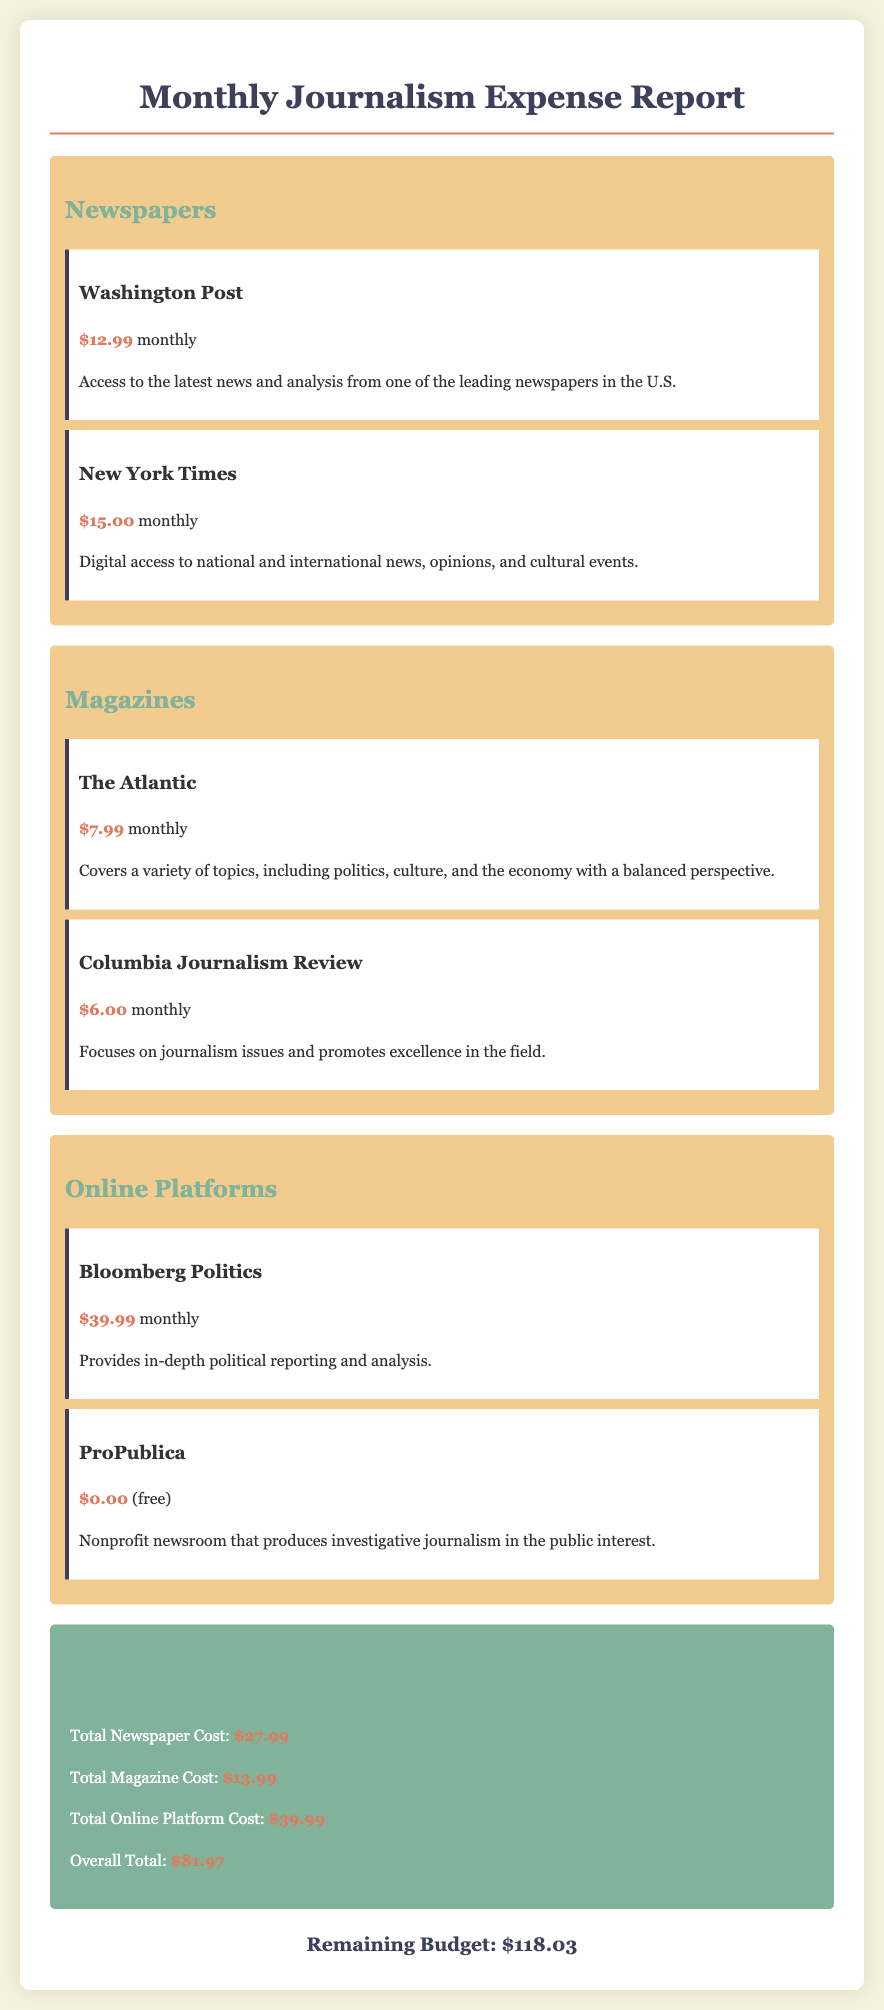What is the total cost for newspapers? The total cost for newspapers is calculated by adding the individual costs of the Washington Post and the New York Times, which are $12.99 and $15.00, respectively.
Answer: $27.99 How much does a subscription to The Atlantic cost? The cost of a subscription to The Atlantic is listed directly under its description.
Answer: $7.99 What is the overall total monthly expense? The overall total monthly expense is clearly stated in the summary section of the document.
Answer: $81.97 How many magazines are listed in the report? The number of magazines is determined by counting the magazine subscription items presented in the report.
Answer: 2 Which online platform has a free subscription? The online platform with a free subscription is mentioned in its subscription details.
Answer: ProPublica What is the remaining budget after expenses? The remaining budget is presented at the bottom of the report as the final amount available.
Answer: $118.03 What is the cost of the Bloomberg Politics subscription? The cost of Bloomberg Politics is reflected directly in its subscription description.
Answer: $39.99 What type of journalism does the Columbia Journalism Review focus on? The focus of the Columbia Journalism Review is indicated in its description related to journalism issues.
Answer: Journalism issues 